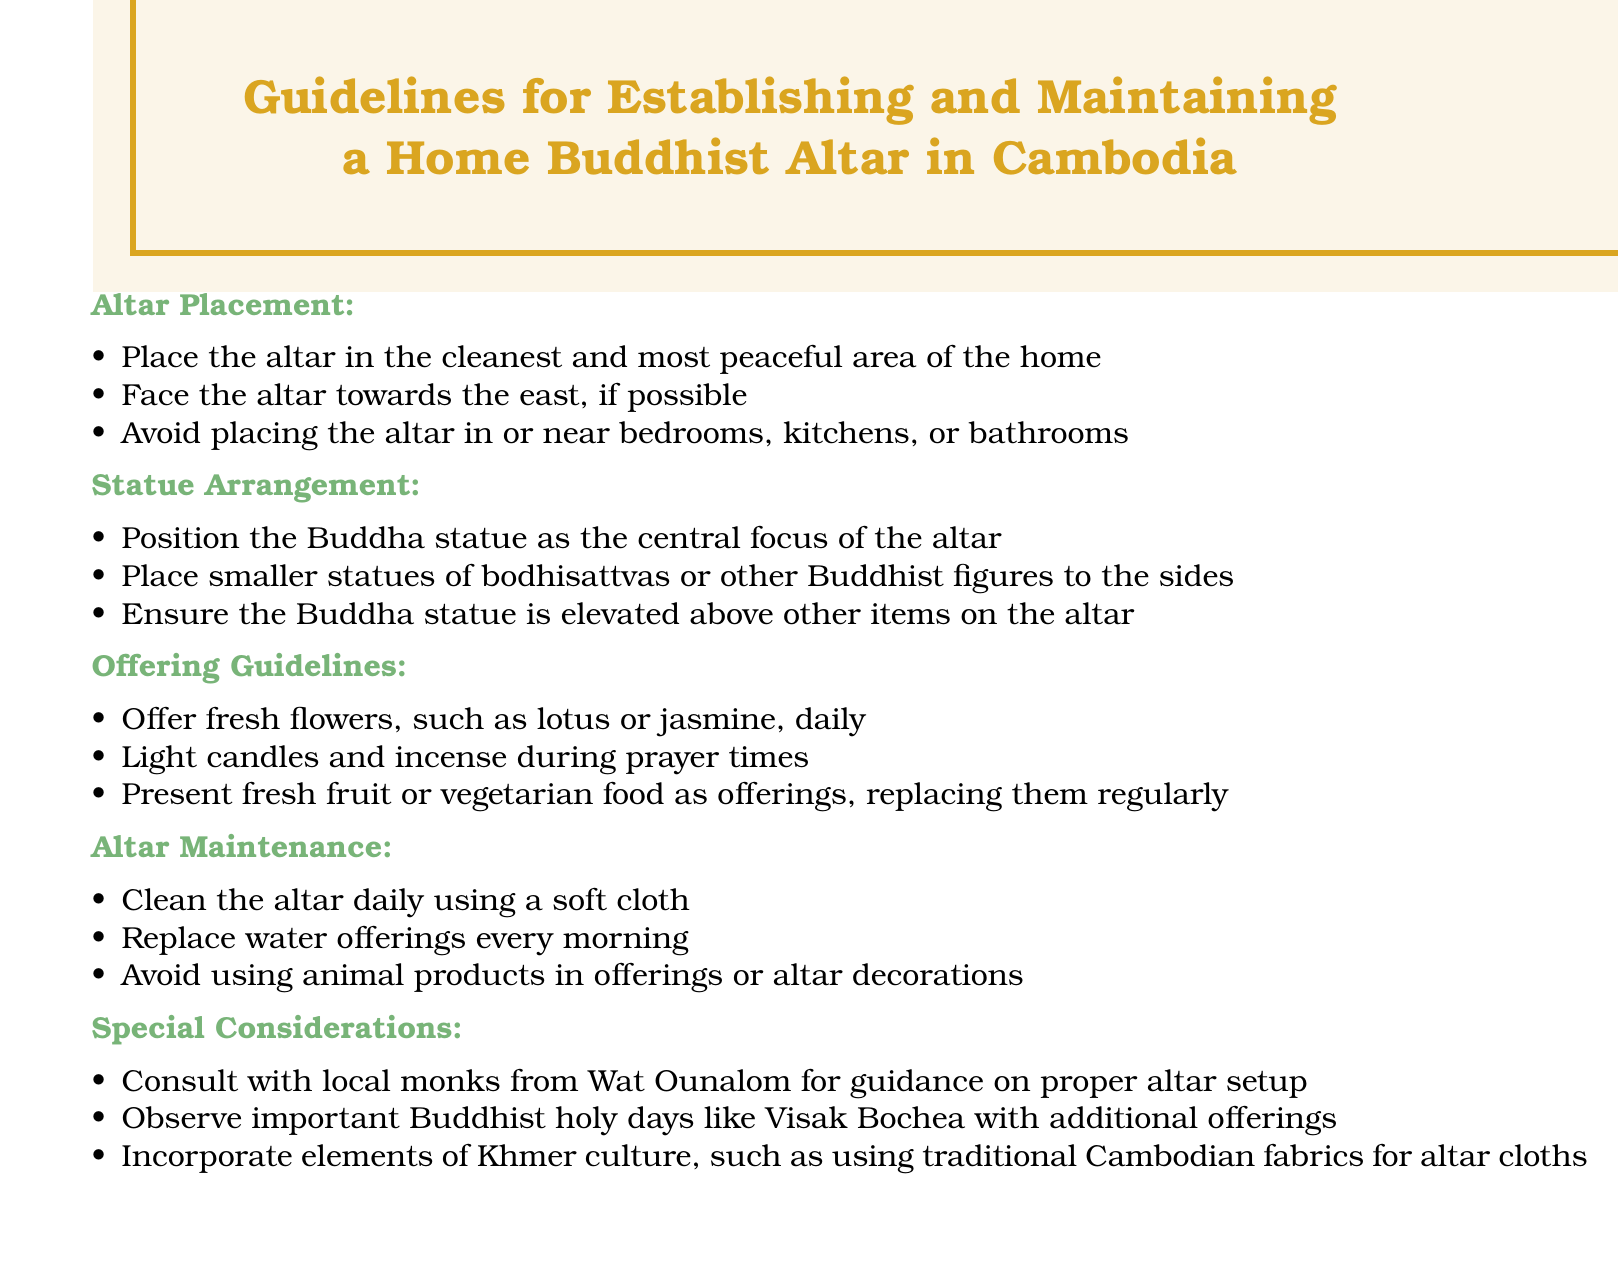what is the cleanest area in the home for an altar? The document states that the altar should be placed in the cleanest and most peaceful area of the home.
Answer: cleanest area which direction should the altar face? The document recommends facing the altar towards the east, if possible.
Answer: east what type of flowers should be offered daily? The document specifies that fresh flowers such as lotus or jasmine should be offered daily.
Answer: lotus or jasmine how often should the altar be cleaned? According to the guidelines, the altar should be cleaned daily.
Answer: daily who should be consulted for guidance on proper altar setup? The document mentions consulting with local monks from Wat Ounalom for guidance.
Answer: local monks from Wat Ounalom what is the central focus of the altar? The guidelines state that the Buddha statue should be the central focus of the altar.
Answer: Buddha statue which type of food should be offered? The document advises presenting fresh fruit or vegetarian food as offerings.
Answer: fresh fruit or vegetarian food what materials should be avoided in offerings? The guidelines indicate avoiding animal products in offerings or altar decorations.
Answer: animal products what is a special consideration for holidays? The document indicates observing important Buddhist holy days, like Visak Bochea, with additional offerings.
Answer: additional offerings 